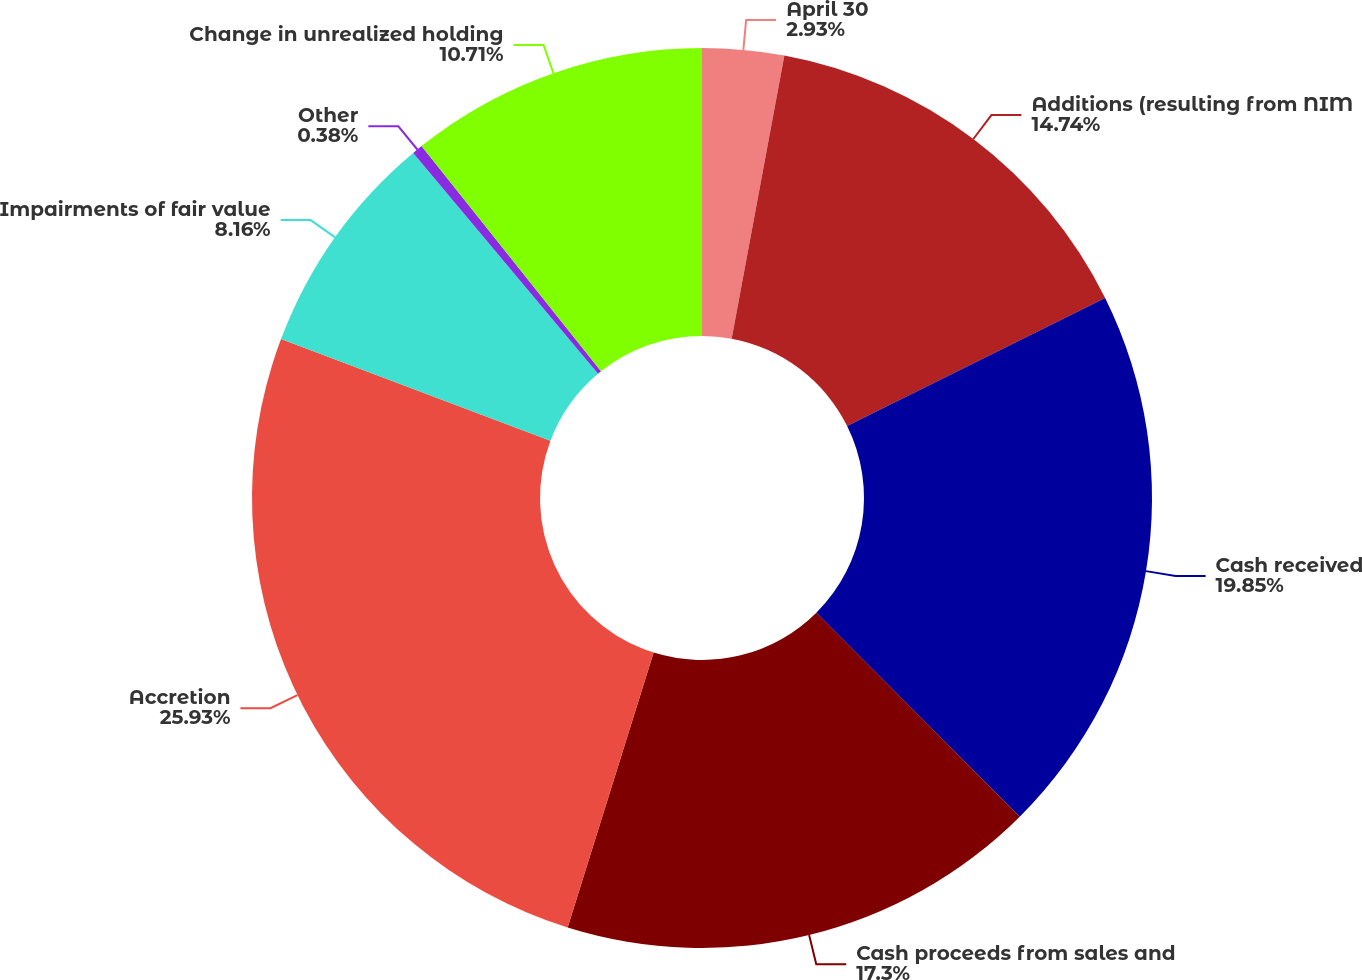Convert chart to OTSL. <chart><loc_0><loc_0><loc_500><loc_500><pie_chart><fcel>April 30<fcel>Additions (resulting from NIM<fcel>Cash received<fcel>Cash proceeds from sales and<fcel>Accretion<fcel>Impairments of fair value<fcel>Other<fcel>Change in unrealized holding<nl><fcel>2.93%<fcel>14.74%<fcel>19.85%<fcel>17.3%<fcel>25.92%<fcel>8.16%<fcel>0.38%<fcel>10.71%<nl></chart> 